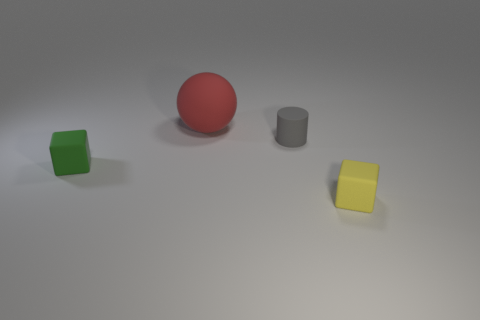Add 3 green objects. How many objects exist? 7 Subtract 0 purple cylinders. How many objects are left? 4 Subtract all matte things. Subtract all small metal cubes. How many objects are left? 0 Add 3 large rubber things. How many large rubber things are left? 4 Add 3 gray cylinders. How many gray cylinders exist? 4 